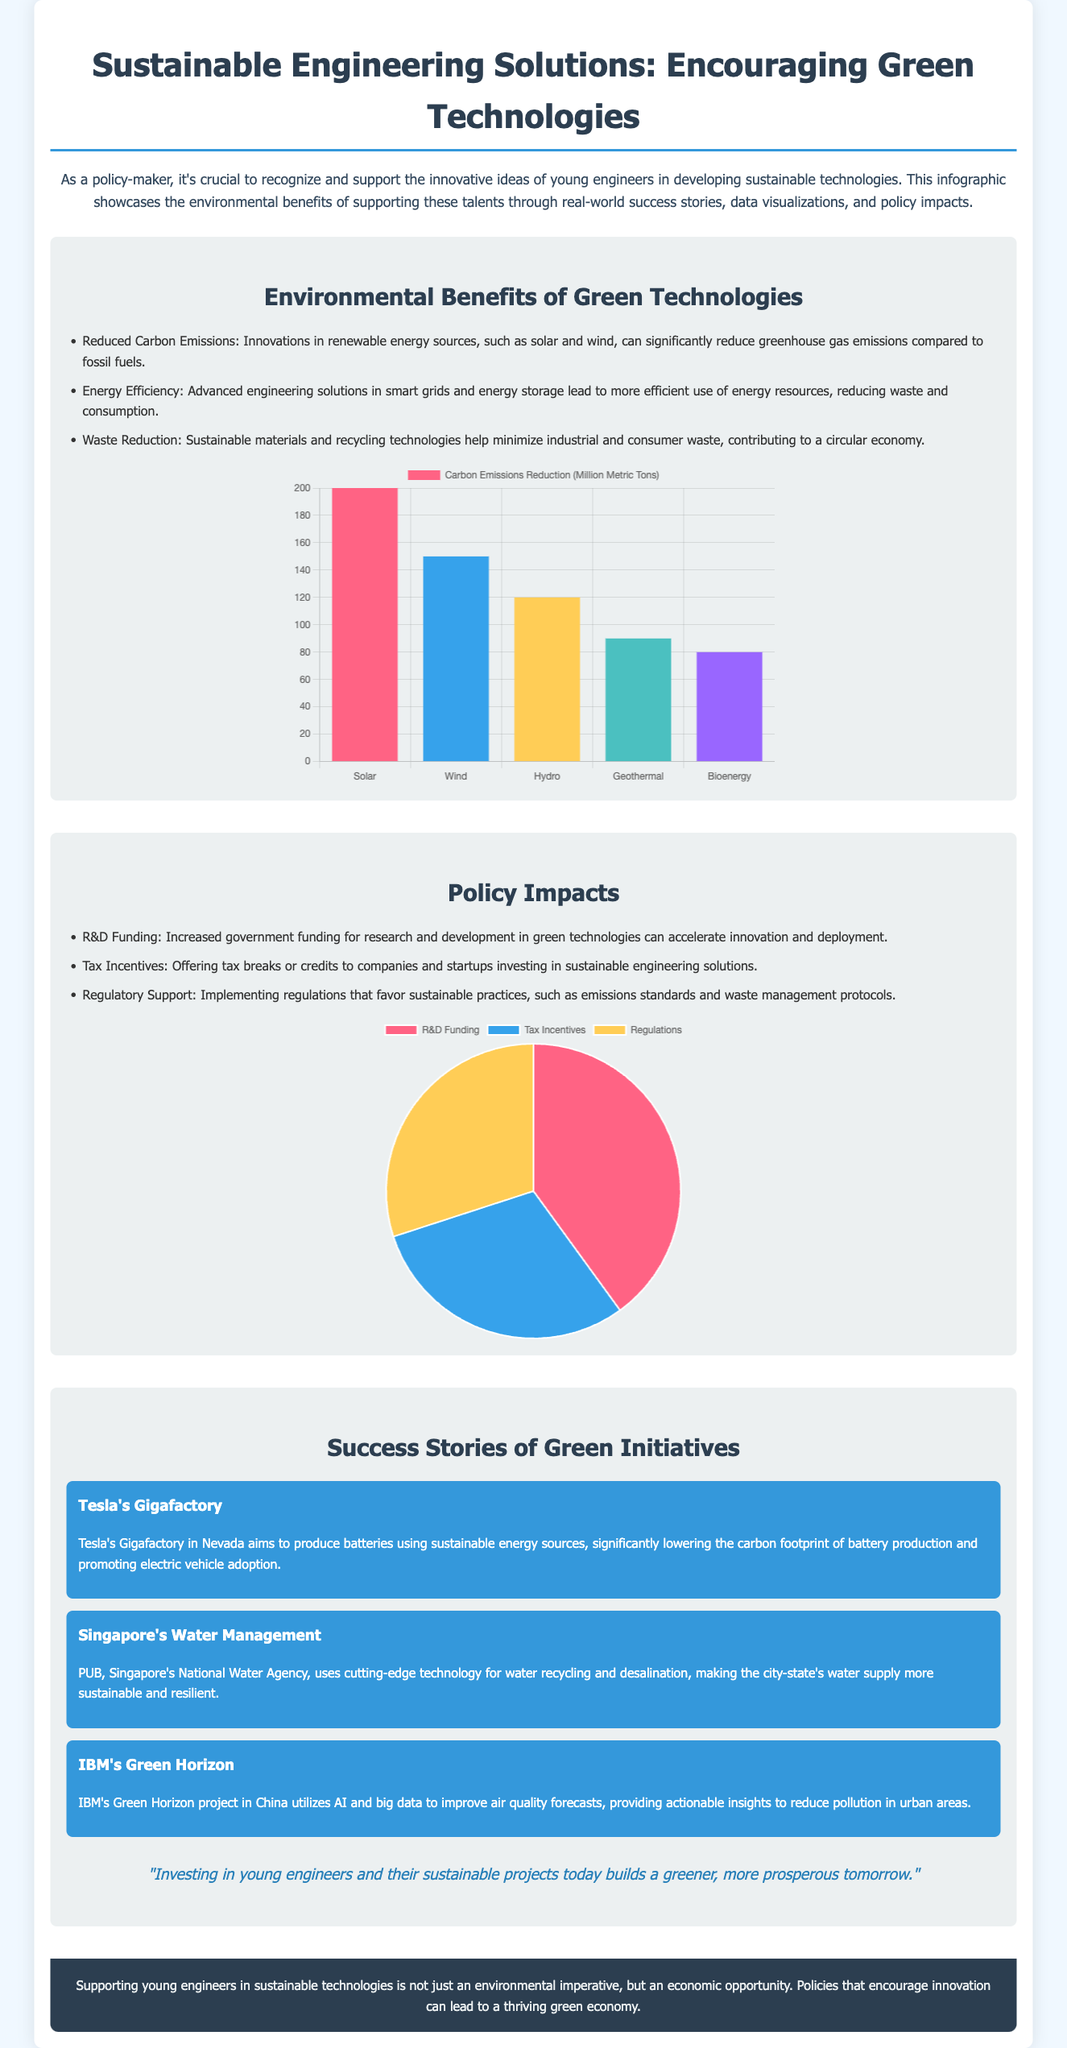What is the title of the document? The title is stated at the top of the document.
Answer: Sustainable Engineering Solutions: Encouraging Green Technologies How many types of green technologies are mentioned in the environmental benefits section? The document lists three types of environmental benefits.
Answer: Three What does Tesla's Gigafactory aim to produce? The success story mentions the specific aim of the Gigafactory.
Answer: Batteries What percentage of the policy impacts is attributed to R&D funding? The pie chart indicates the percentage related to R&D funding.
Answer: 40 How many successful green initiatives are showcased in the document? The success stories section lists a specific number of initiatives.
Answer: Three What is the main color used in the emissions reduction chart for wind energy? The document describes the colors used for each type of energy.
Answer: Blue What is the environmental imperative discussed in the footer? The footer summarizes the key idea presented in the document.
Answer: Economic opportunity Which technology has the highest carbon emissions reduction? The emissions chart provides data for various technologies.
Answer: Solar 